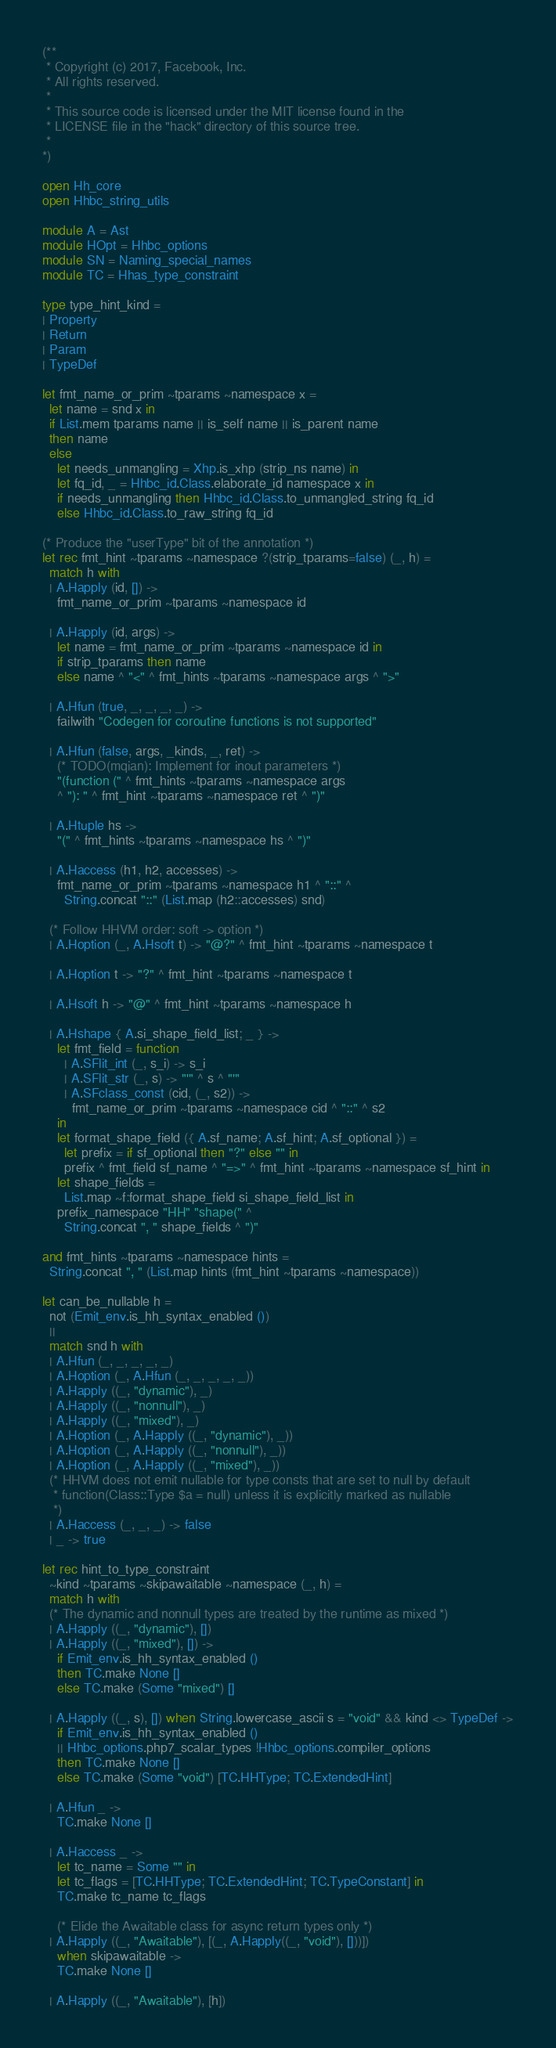<code> <loc_0><loc_0><loc_500><loc_500><_OCaml_>(**
 * Copyright (c) 2017, Facebook, Inc.
 * All rights reserved.
 *
 * This source code is licensed under the MIT license found in the
 * LICENSE file in the "hack" directory of this source tree.
 *
*)

open Hh_core
open Hhbc_string_utils

module A = Ast
module HOpt = Hhbc_options
module SN = Naming_special_names
module TC = Hhas_type_constraint

type type_hint_kind =
| Property
| Return
| Param
| TypeDef

let fmt_name_or_prim ~tparams ~namespace x =
  let name = snd x in
  if List.mem tparams name || is_self name || is_parent name
  then name
  else
    let needs_unmangling = Xhp.is_xhp (strip_ns name) in
    let fq_id, _ = Hhbc_id.Class.elaborate_id namespace x in
    if needs_unmangling then Hhbc_id.Class.to_unmangled_string fq_id
    else Hhbc_id.Class.to_raw_string fq_id

(* Produce the "userType" bit of the annotation *)
let rec fmt_hint ~tparams ~namespace ?(strip_tparams=false) (_, h) =
  match h with
  | A.Happly (id, []) ->
    fmt_name_or_prim ~tparams ~namespace id

  | A.Happly (id, args) ->
    let name = fmt_name_or_prim ~tparams ~namespace id in
    if strip_tparams then name
    else name ^ "<" ^ fmt_hints ~tparams ~namespace args ^ ">"

  | A.Hfun (true, _, _, _, _) ->
    failwith "Codegen for coroutine functions is not supported"

  | A.Hfun (false, args, _kinds, _, ret) ->
    (* TODO(mqian): Implement for inout parameters *)
    "(function (" ^ fmt_hints ~tparams ~namespace args
    ^ "): " ^ fmt_hint ~tparams ~namespace ret ^ ")"

  | A.Htuple hs ->
    "(" ^ fmt_hints ~tparams ~namespace hs ^ ")"

  | A.Haccess (h1, h2, accesses) ->
    fmt_name_or_prim ~tparams ~namespace h1 ^ "::" ^
      String.concat "::" (List.map (h2::accesses) snd)

  (* Follow HHVM order: soft -> option *)
  | A.Hoption (_, A.Hsoft t) -> "@?" ^ fmt_hint ~tparams ~namespace t

  | A.Hoption t -> "?" ^ fmt_hint ~tparams ~namespace t

  | A.Hsoft h -> "@" ^ fmt_hint ~tparams ~namespace h

  | A.Hshape { A.si_shape_field_list; _ } ->
    let fmt_field = function
      | A.SFlit_int (_, s_i) -> s_i
      | A.SFlit_str (_, s) -> "'" ^ s ^ "'"
      | A.SFclass_const (cid, (_, s2)) ->
        fmt_name_or_prim ~tparams ~namespace cid ^ "::" ^ s2
    in
    let format_shape_field ({ A.sf_name; A.sf_hint; A.sf_optional }) =
      let prefix = if sf_optional then "?" else "" in
      prefix ^ fmt_field sf_name ^ "=>" ^ fmt_hint ~tparams ~namespace sf_hint in
    let shape_fields =
      List.map ~f:format_shape_field si_shape_field_list in
    prefix_namespace "HH" "shape(" ^
      String.concat ", " shape_fields ^ ")"

and fmt_hints ~tparams ~namespace hints =
  String.concat ", " (List.map hints (fmt_hint ~tparams ~namespace))

let can_be_nullable h =
  not (Emit_env.is_hh_syntax_enabled ())
  ||
  match snd h with
  | A.Hfun (_, _, _, _, _)
  | A.Hoption (_, A.Hfun (_, _, _, _, _))
  | A.Happly ((_, "dynamic"), _)
  | A.Happly ((_, "nonnull"), _)
  | A.Happly ((_, "mixed"), _)
  | A.Hoption (_, A.Happly ((_, "dynamic"), _))
  | A.Hoption (_, A.Happly ((_, "nonnull"), _))
  | A.Hoption (_, A.Happly ((_, "mixed"), _))
  (* HHVM does not emit nullable for type consts that are set to null by default
   * function(Class::Type $a = null) unless it is explicitly marked as nullable
   *)
  | A.Haccess (_, _, _) -> false
  | _ -> true

let rec hint_to_type_constraint
  ~kind ~tparams ~skipawaitable ~namespace (_, h) =
  match h with
  (* The dynamic and nonnull types are treated by the runtime as mixed *)
  | A.Happly ((_, "dynamic"), [])
  | A.Happly ((_, "mixed"), []) ->
    if Emit_env.is_hh_syntax_enabled ()
    then TC.make None []
    else TC.make (Some "mixed") []

  | A.Happly ((_, s), []) when String.lowercase_ascii s = "void" && kind <> TypeDef ->
    if Emit_env.is_hh_syntax_enabled ()
    || Hhbc_options.php7_scalar_types !Hhbc_options.compiler_options
    then TC.make None []
    else TC.make (Some "void") [TC.HHType; TC.ExtendedHint]

  | A.Hfun _ ->
    TC.make None []

  | A.Haccess _ ->
    let tc_name = Some "" in
    let tc_flags = [TC.HHType; TC.ExtendedHint; TC.TypeConstant] in
    TC.make tc_name tc_flags

    (* Elide the Awaitable class for async return types only *)
  | A.Happly ((_, "Awaitable"), [(_, A.Happly((_, "void"), []))])
    when skipawaitable ->
    TC.make None []

  | A.Happly ((_, "Awaitable"), [h])</code> 